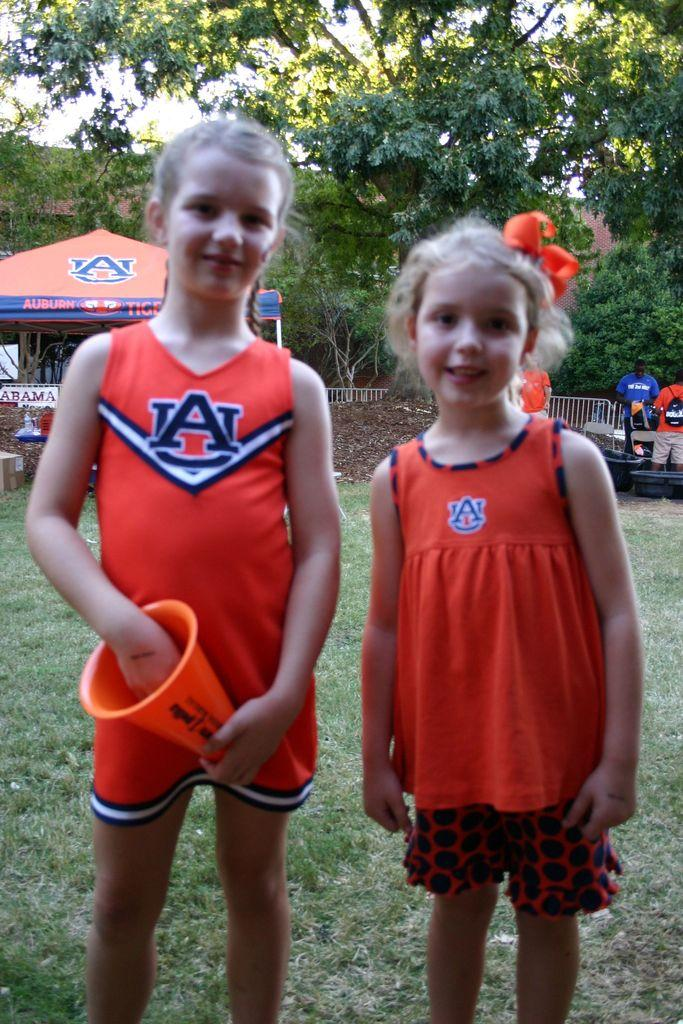<image>
Present a compact description of the photo's key features. Two little girls in orange Auburn outfits stand outside with a Auburn tent set up in the back. 